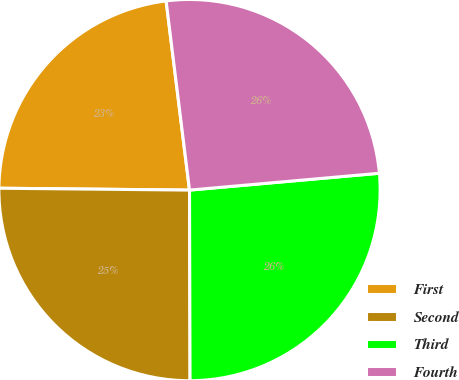<chart> <loc_0><loc_0><loc_500><loc_500><pie_chart><fcel>First<fcel>Second<fcel>Third<fcel>Fourth<nl><fcel>22.88%<fcel>25.2%<fcel>26.36%<fcel>25.55%<nl></chart> 